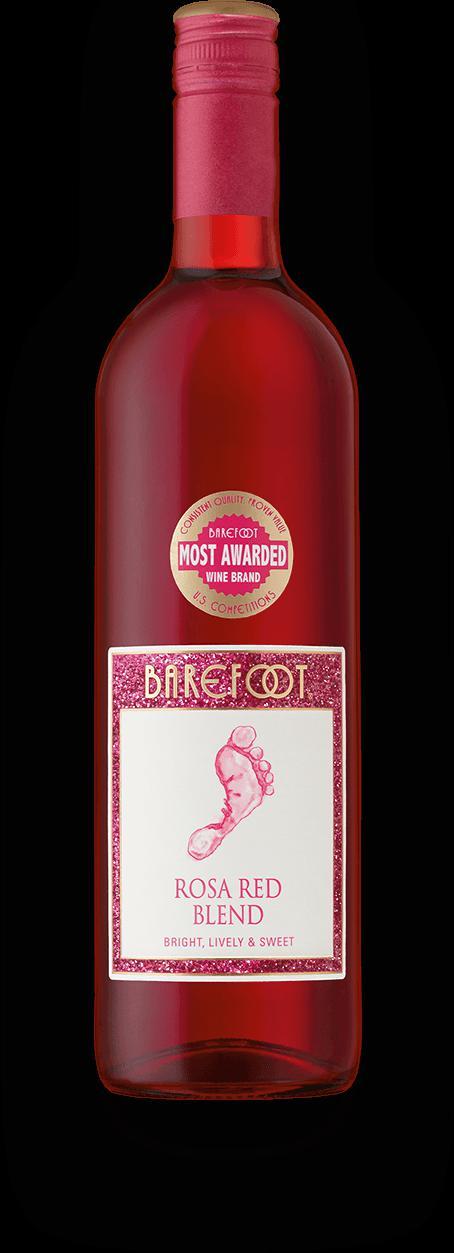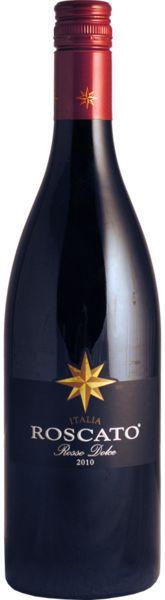The first image is the image on the left, the second image is the image on the right. Examine the images to the left and right. Is the description "All bottles are dark with red trim and withthe same long-necked shape." accurate? Answer yes or no. No. 